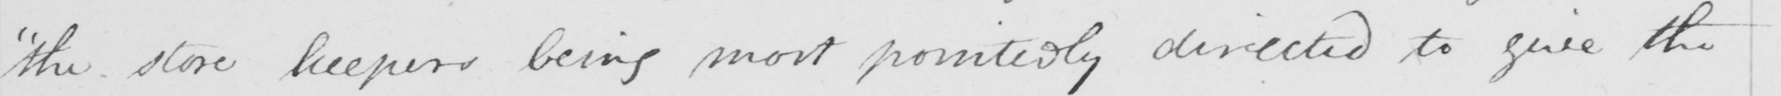Please provide the text content of this handwritten line. " the store keepers being most pointedly directed to give the 